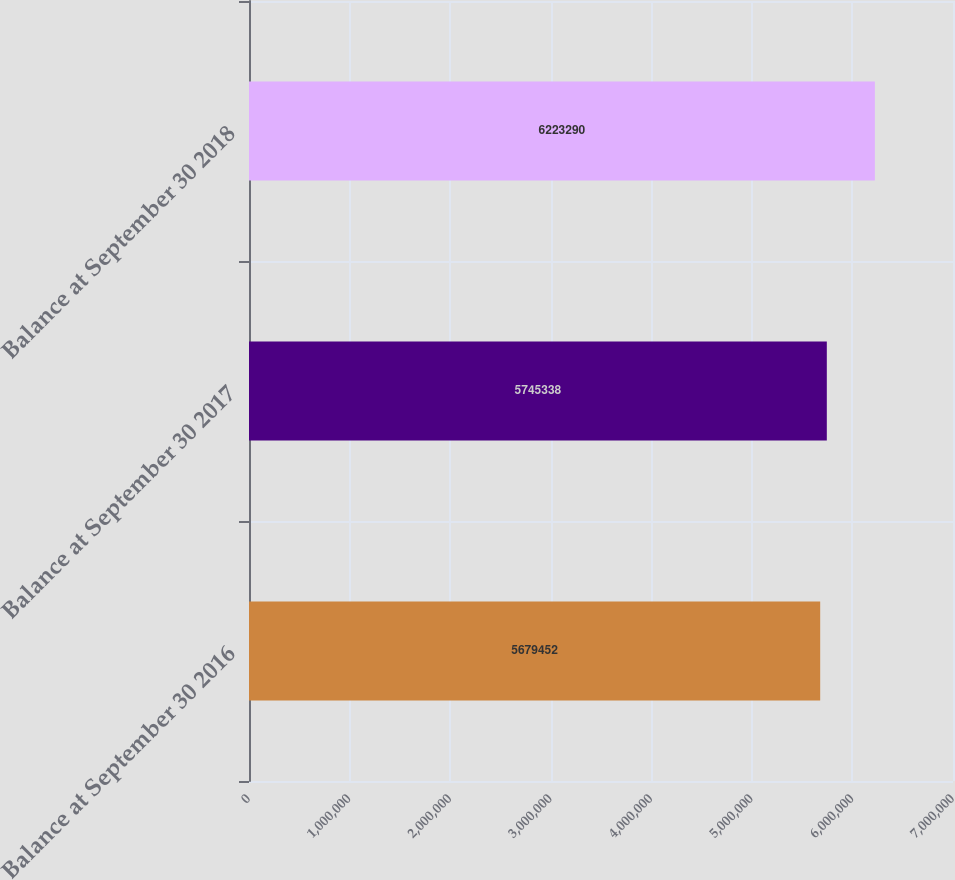<chart> <loc_0><loc_0><loc_500><loc_500><bar_chart><fcel>Balance at September 30 2016<fcel>Balance at September 30 2017<fcel>Balance at September 30 2018<nl><fcel>5.67945e+06<fcel>5.74534e+06<fcel>6.22329e+06<nl></chart> 